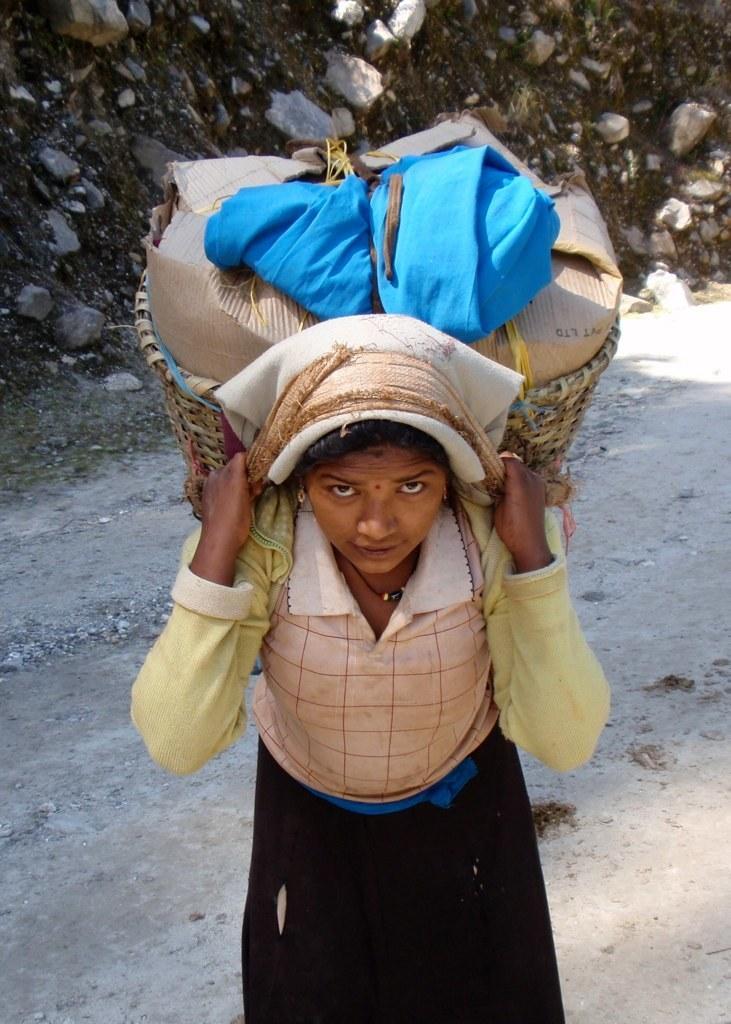Please provide a concise description of this image. In the picture there is a woman, the woman is carrying a jute basket, in the basket there are some items present, behind the woman there stones present. 